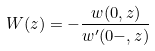Convert formula to latex. <formula><loc_0><loc_0><loc_500><loc_500>W ( z ) = - \frac { w ( 0 , z ) } { w ^ { \prime } ( 0 - , z ) }</formula> 